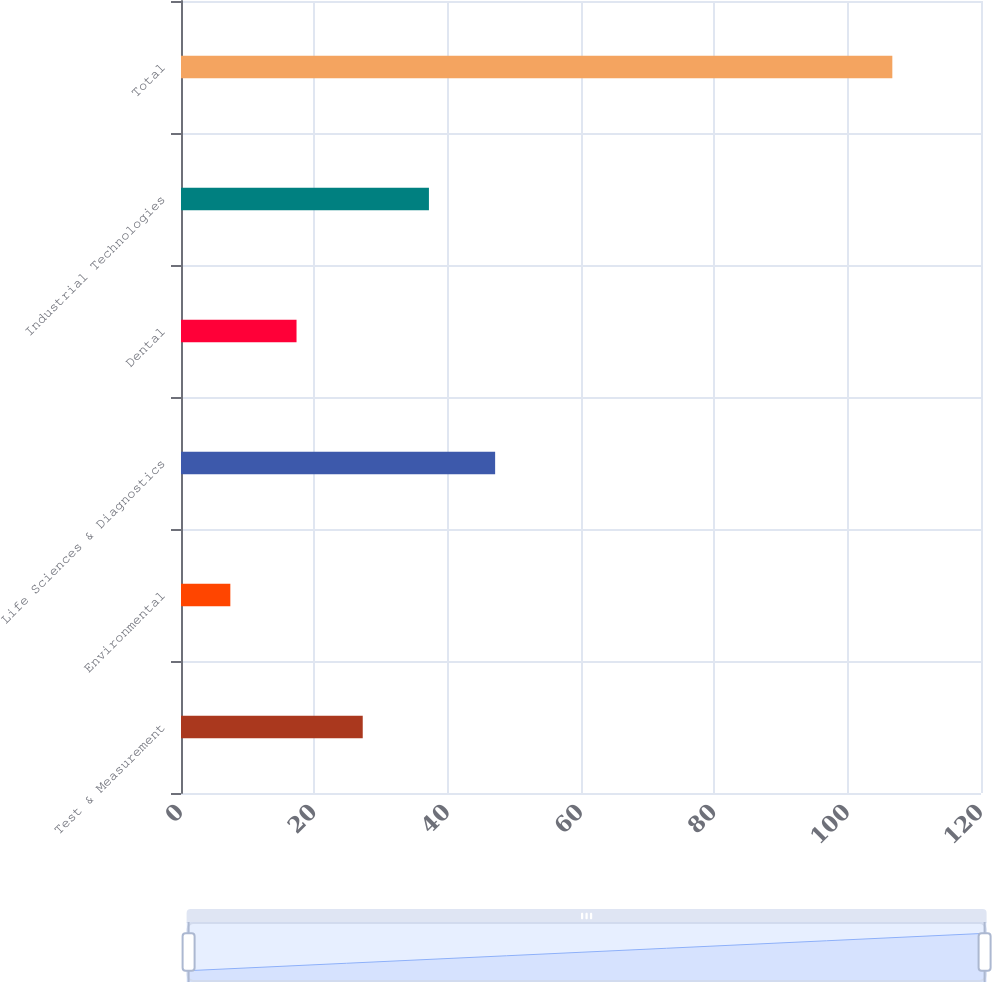Convert chart. <chart><loc_0><loc_0><loc_500><loc_500><bar_chart><fcel>Test & Measurement<fcel>Environmental<fcel>Life Sciences & Diagnostics<fcel>Dental<fcel>Industrial Technologies<fcel>Total<nl><fcel>27.26<fcel>7.4<fcel>47.12<fcel>17.33<fcel>37.19<fcel>106.7<nl></chart> 